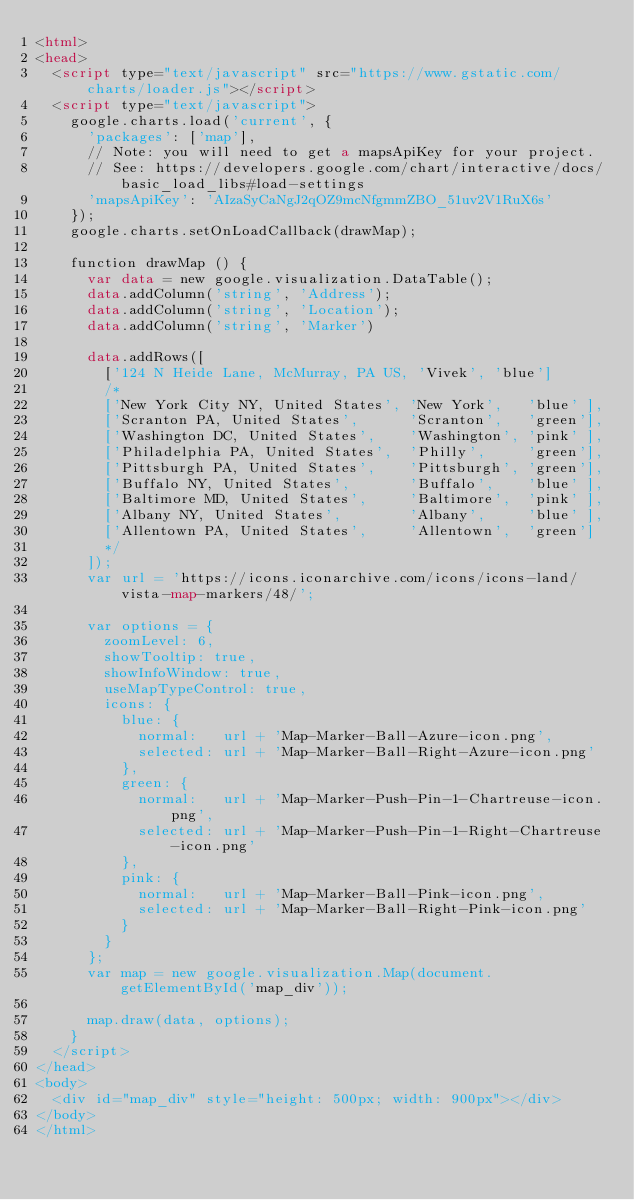Convert code to text. <code><loc_0><loc_0><loc_500><loc_500><_HTML_><html>
<head>
  <script type="text/javascript" src="https://www.gstatic.com/charts/loader.js"></script>
  <script type="text/javascript">
    google.charts.load('current', {
      'packages': ['map'],
      // Note: you will need to get a mapsApiKey for your project.
      // See: https://developers.google.com/chart/interactive/docs/basic_load_libs#load-settings
      'mapsApiKey': 'AIzaSyCaNgJ2qOZ9mcNfgmmZBO_51uv2V1RuX6s'
    });
    google.charts.setOnLoadCallback(drawMap);

    function drawMap () {
      var data = new google.visualization.DataTable();
      data.addColumn('string', 'Address');
      data.addColumn('string', 'Location');
      data.addColumn('string', 'Marker')

      data.addRows([
        ['124 N Heide Lane, McMurray, PA US, 'Vivek', 'blue']
        /*
        ['New York City NY, United States', 'New York',   'blue' ],
        ['Scranton PA, United States',      'Scranton',   'green'],
        ['Washington DC, United States',    'Washington', 'pink' ],
        ['Philadelphia PA, United States',  'Philly',     'green'],
        ['Pittsburgh PA, United States',    'Pittsburgh', 'green'],
        ['Buffalo NY, United States',       'Buffalo',    'blue' ],
        ['Baltimore MD, United States',     'Baltimore',  'pink' ],
        ['Albany NY, United States',        'Albany',     'blue' ],
        ['Allentown PA, United States',     'Allentown',  'green']
        */
      ]);
      var url = 'https://icons.iconarchive.com/icons/icons-land/vista-map-markers/48/';

      var options = {
        zoomLevel: 6,
        showTooltip: true,
        showInfoWindow: true,
        useMapTypeControl: true,
        icons: {
          blue: {
            normal:   url + 'Map-Marker-Ball-Azure-icon.png',
            selected: url + 'Map-Marker-Ball-Right-Azure-icon.png'
          },
          green: {
            normal:   url + 'Map-Marker-Push-Pin-1-Chartreuse-icon.png',
            selected: url + 'Map-Marker-Push-Pin-1-Right-Chartreuse-icon.png'
          },
          pink: {
            normal:   url + 'Map-Marker-Ball-Pink-icon.png',
            selected: url + 'Map-Marker-Ball-Right-Pink-icon.png'
          }
        }
      };
      var map = new google.visualization.Map(document.getElementById('map_div'));

      map.draw(data, options);
    }
  </script>
</head>
<body>
  <div id="map_div" style="height: 500px; width: 900px"></div>
</body>
</html>
</code> 